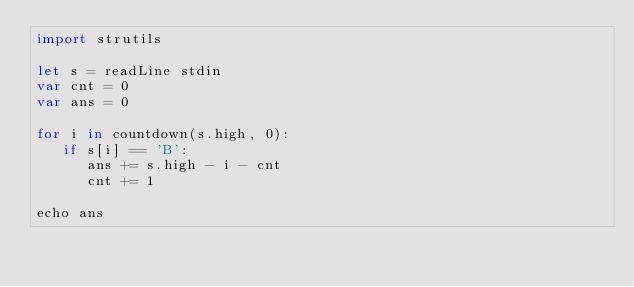Convert code to text. <code><loc_0><loc_0><loc_500><loc_500><_Nim_>import strutils

let s = readLine stdin
var cnt = 0
var ans = 0

for i in countdown(s.high, 0):
   if s[i] == 'B':
      ans += s.high - i - cnt
      cnt += 1
   
echo ans

</code> 